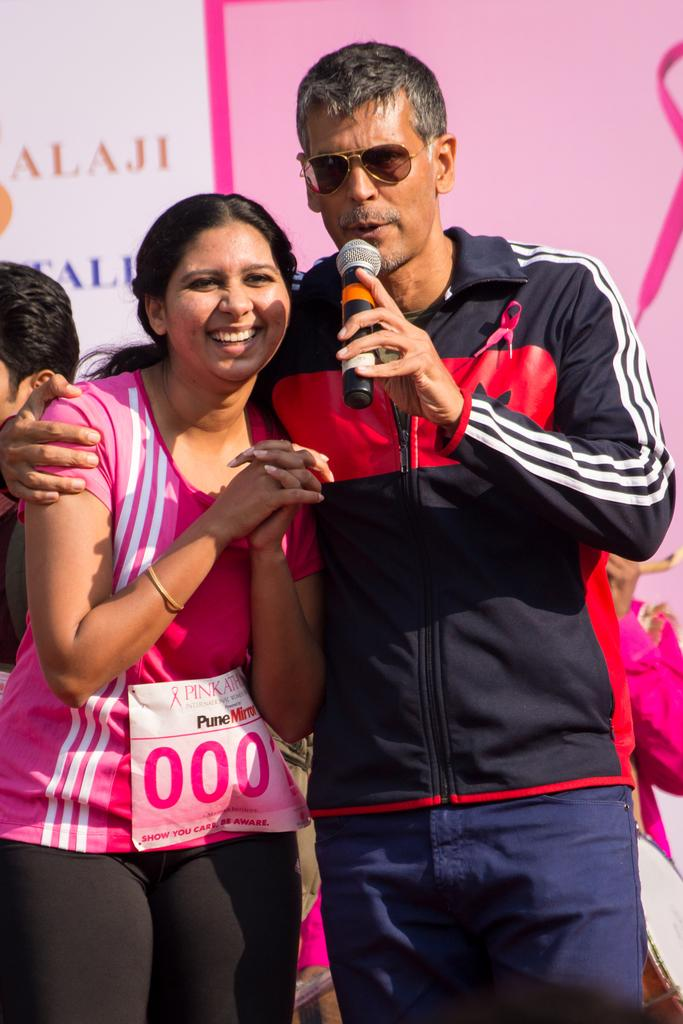What is the man in the image holding in his hand? The man is holding a mic in his hand. Can you describe the man's appearance? The man is wearing glasses. Who is standing beside the man? There is a woman standing beside the man. What can be seen in the background of the image? There is a pink poster in the background of the image. What is written on the pink poster? The pink poster has some text on it. How many cows are visible in the image? There are no cows present in the image. What is the man saying good-bye to in the image? The man is not saying good-bye to anyone in the image; he is holding a mic. 